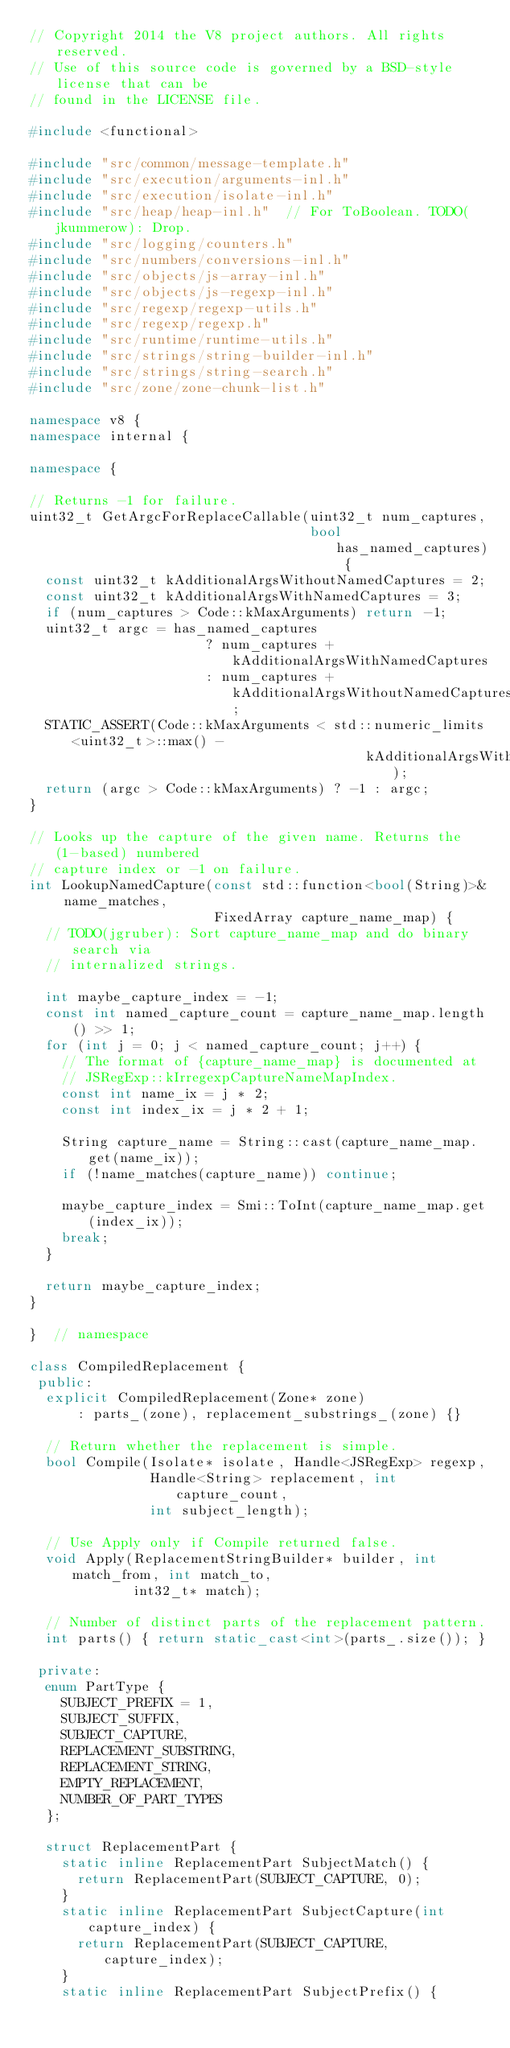<code> <loc_0><loc_0><loc_500><loc_500><_C++_>// Copyright 2014 the V8 project authors. All rights reserved.
// Use of this source code is governed by a BSD-style license that can be
// found in the LICENSE file.

#include <functional>

#include "src/common/message-template.h"
#include "src/execution/arguments-inl.h"
#include "src/execution/isolate-inl.h"
#include "src/heap/heap-inl.h"  // For ToBoolean. TODO(jkummerow): Drop.
#include "src/logging/counters.h"
#include "src/numbers/conversions-inl.h"
#include "src/objects/js-array-inl.h"
#include "src/objects/js-regexp-inl.h"
#include "src/regexp/regexp-utils.h"
#include "src/regexp/regexp.h"
#include "src/runtime/runtime-utils.h"
#include "src/strings/string-builder-inl.h"
#include "src/strings/string-search.h"
#include "src/zone/zone-chunk-list.h"

namespace v8 {
namespace internal {

namespace {

// Returns -1 for failure.
uint32_t GetArgcForReplaceCallable(uint32_t num_captures,
                                   bool has_named_captures) {
  const uint32_t kAdditionalArgsWithoutNamedCaptures = 2;
  const uint32_t kAdditionalArgsWithNamedCaptures = 3;
  if (num_captures > Code::kMaxArguments) return -1;
  uint32_t argc = has_named_captures
                      ? num_captures + kAdditionalArgsWithNamedCaptures
                      : num_captures + kAdditionalArgsWithoutNamedCaptures;
  STATIC_ASSERT(Code::kMaxArguments < std::numeric_limits<uint32_t>::max() -
                                          kAdditionalArgsWithNamedCaptures);
  return (argc > Code::kMaxArguments) ? -1 : argc;
}

// Looks up the capture of the given name. Returns the (1-based) numbered
// capture index or -1 on failure.
int LookupNamedCapture(const std::function<bool(String)>& name_matches,
                       FixedArray capture_name_map) {
  // TODO(jgruber): Sort capture_name_map and do binary search via
  // internalized strings.

  int maybe_capture_index = -1;
  const int named_capture_count = capture_name_map.length() >> 1;
  for (int j = 0; j < named_capture_count; j++) {
    // The format of {capture_name_map} is documented at
    // JSRegExp::kIrregexpCaptureNameMapIndex.
    const int name_ix = j * 2;
    const int index_ix = j * 2 + 1;

    String capture_name = String::cast(capture_name_map.get(name_ix));
    if (!name_matches(capture_name)) continue;

    maybe_capture_index = Smi::ToInt(capture_name_map.get(index_ix));
    break;
  }

  return maybe_capture_index;
}

}  // namespace

class CompiledReplacement {
 public:
  explicit CompiledReplacement(Zone* zone)
      : parts_(zone), replacement_substrings_(zone) {}

  // Return whether the replacement is simple.
  bool Compile(Isolate* isolate, Handle<JSRegExp> regexp,
               Handle<String> replacement, int capture_count,
               int subject_length);

  // Use Apply only if Compile returned false.
  void Apply(ReplacementStringBuilder* builder, int match_from, int match_to,
             int32_t* match);

  // Number of distinct parts of the replacement pattern.
  int parts() { return static_cast<int>(parts_.size()); }

 private:
  enum PartType {
    SUBJECT_PREFIX = 1,
    SUBJECT_SUFFIX,
    SUBJECT_CAPTURE,
    REPLACEMENT_SUBSTRING,
    REPLACEMENT_STRING,
    EMPTY_REPLACEMENT,
    NUMBER_OF_PART_TYPES
  };

  struct ReplacementPart {
    static inline ReplacementPart SubjectMatch() {
      return ReplacementPart(SUBJECT_CAPTURE, 0);
    }
    static inline ReplacementPart SubjectCapture(int capture_index) {
      return ReplacementPart(SUBJECT_CAPTURE, capture_index);
    }
    static inline ReplacementPart SubjectPrefix() {</code> 